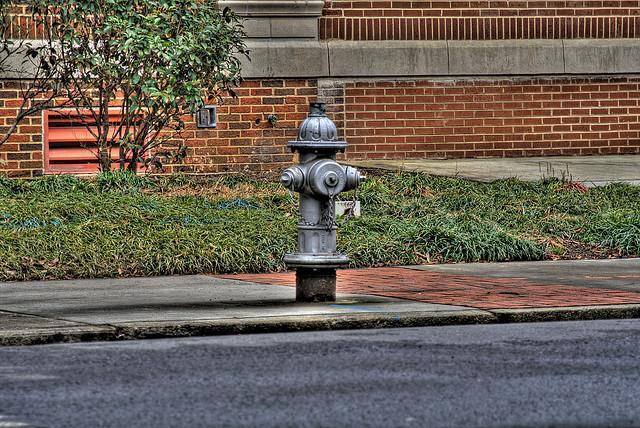How many people on the sidewalk?
Give a very brief answer. 0. 